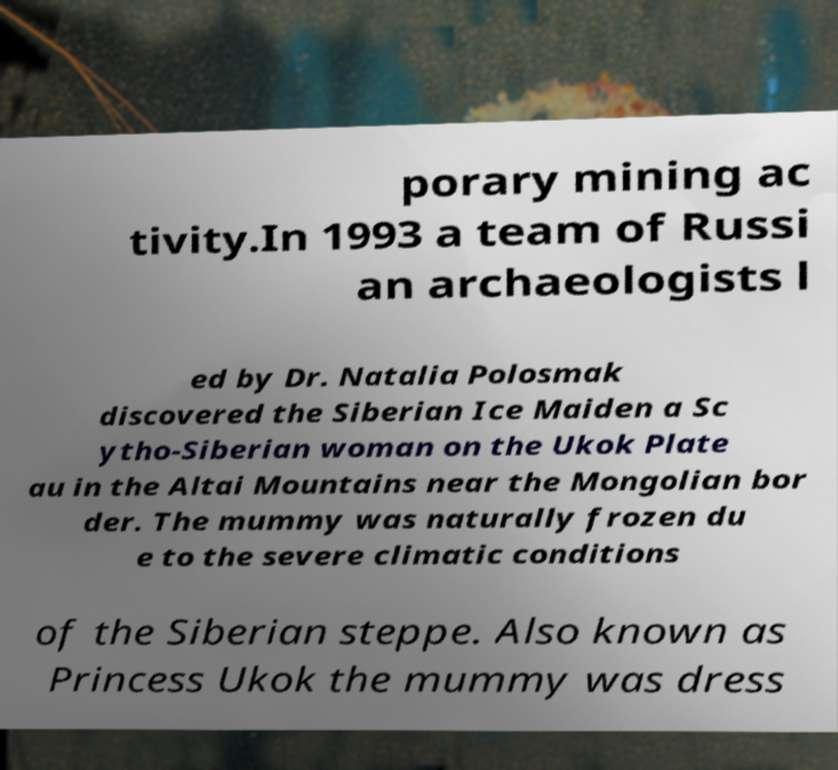What messages or text are displayed in this image? I need them in a readable, typed format. porary mining ac tivity.In 1993 a team of Russi an archaeologists l ed by Dr. Natalia Polosmak discovered the Siberian Ice Maiden a Sc ytho-Siberian woman on the Ukok Plate au in the Altai Mountains near the Mongolian bor der. The mummy was naturally frozen du e to the severe climatic conditions of the Siberian steppe. Also known as Princess Ukok the mummy was dress 